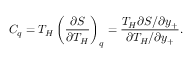Convert formula to latex. <formula><loc_0><loc_0><loc_500><loc_500>C _ { q } = T _ { H } \left ( \frac { \partial S } { \partial T _ { H } } \right ) _ { q } = \frac { T _ { H } \partial S / \partial y _ { + } } { \partial T _ { H } / \partial y _ { + } } .</formula> 